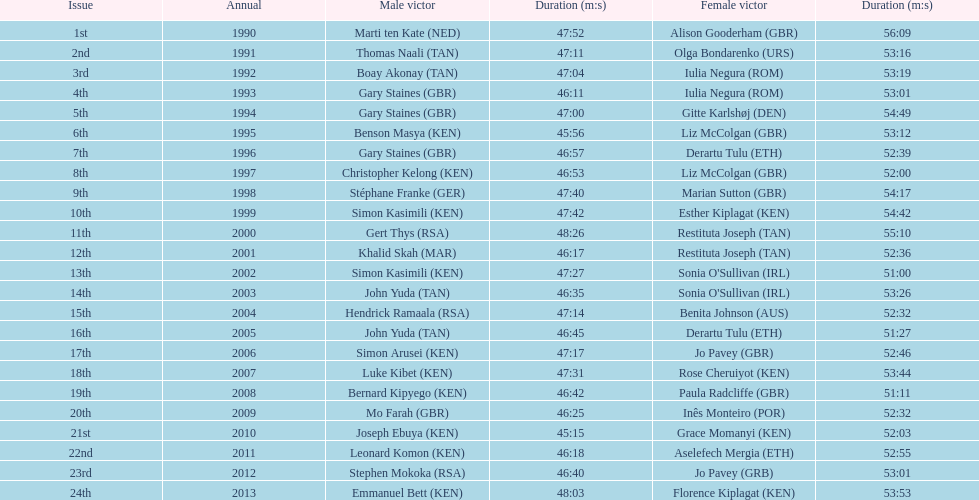What years were the races held? 1990, 1991, 1992, 1993, 1994, 1995, 1996, 1997, 1998, 1999, 2000, 2001, 2002, 2003, 2004, 2005, 2006, 2007, 2008, 2009, 2010, 2011, 2012, 2013. Who was the woman's winner of the 2003 race? Sonia O'Sullivan (IRL). What was her time? 53:26. 